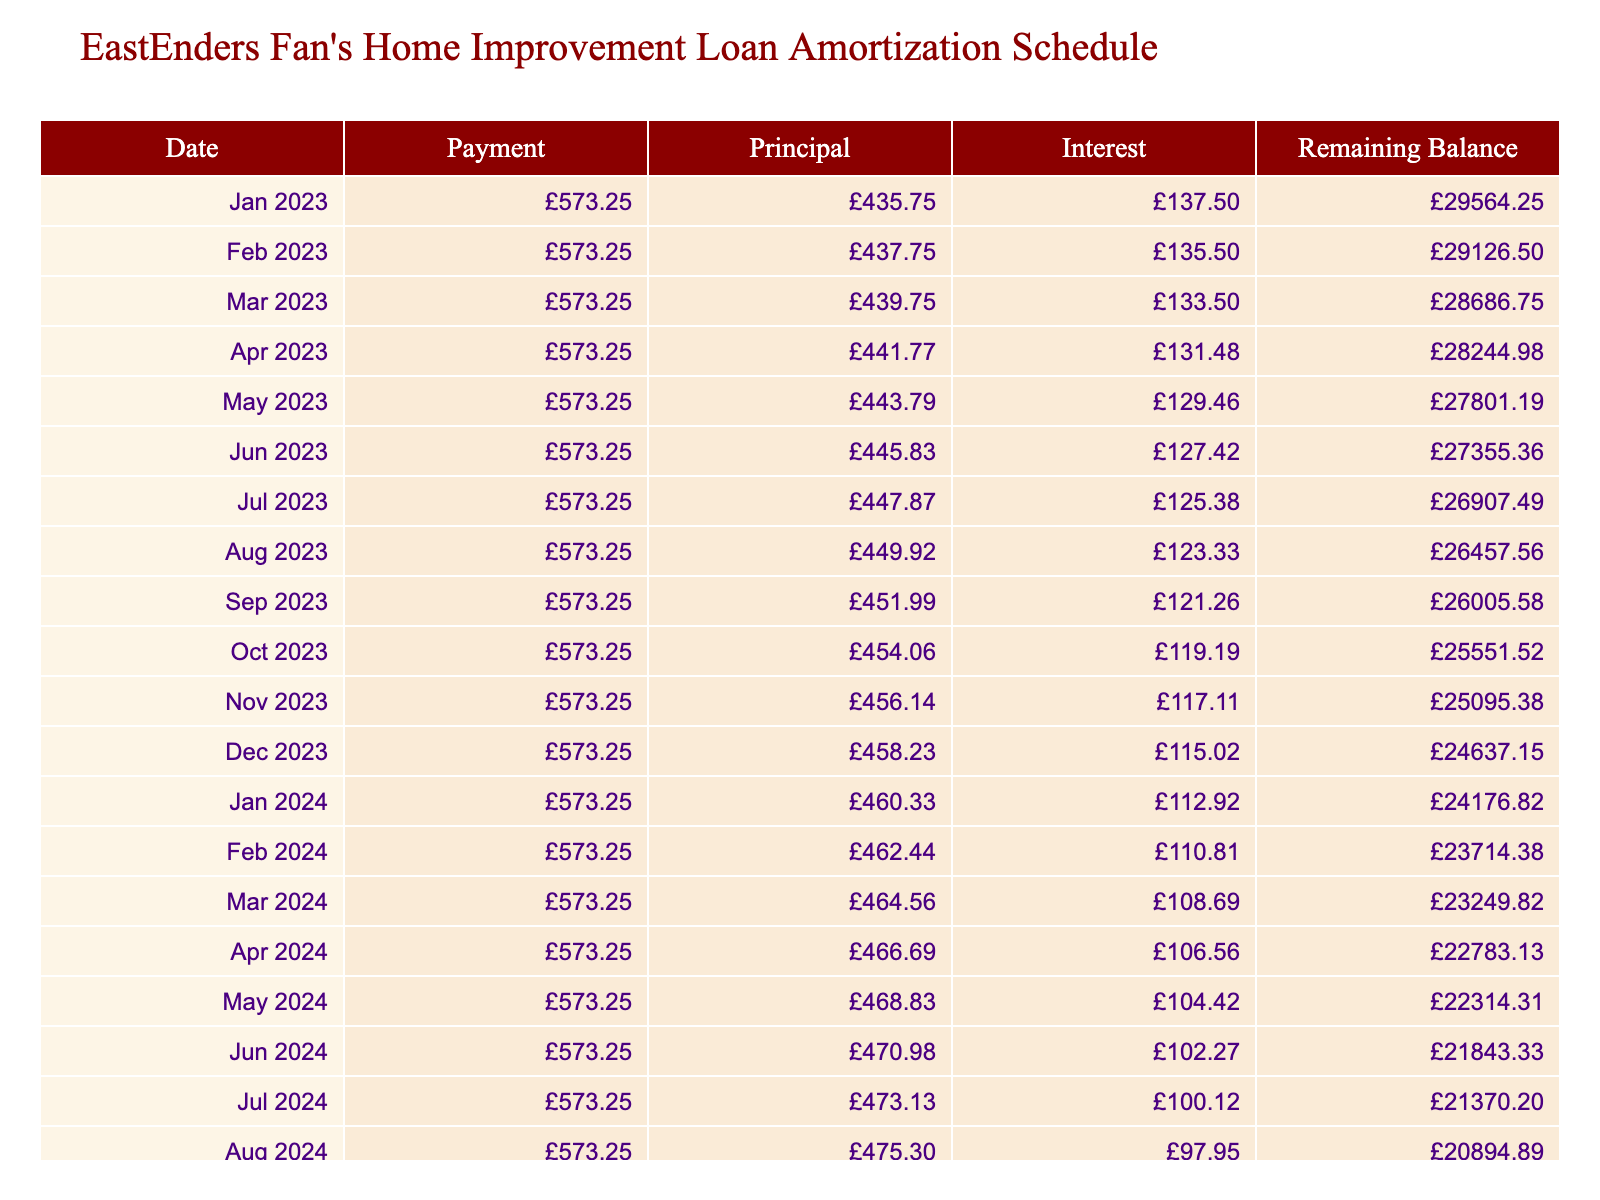What is the loan amount taken out for the home improvement loan? The loan amount is listed directly in the table under "Loan Amount," which shows £30,000.
Answer: £30,000 What is the total interest paid over the loan term? The total interest paid is also specified in the table under "Total Interest Paid," which indicates £4,395.
Answer: £4,395 How much is the monthly payment for this loan? The monthly payment figure is mentioned in the table in the "Monthly Payment" column, which shows £573.25.
Answer: £573.25 What is the remaining balance after the first month? To find the remaining balance after the first month, we take the initial loan amount (£30,000) and subtract the principal payment for the first month. The table will show the remaining balance after calculating this. The remaining balance would be displayed as less than the full loan amount, likely in the table.
Answer: [Value in the table] Is the interest rate of this loan greater than 5%? The interest rate is provided in the table as 5.5%, which is higher than 5%. Thus, the answer is true.
Answer: Yes What is the total payment over the loan term? The total payment is explicitly given in the "Total Payment" column of the table, amounting to £34,395.
Answer: £34,395 By the end of the loan term, what will the remaining balance be? At the end of the loan term, the remaining balance is always paid off, thus it will show £0 in the table. This value can be found by looking at the last row in the additional columns.
Answer: £0 What would be the average monthly interest paid over the life of the loan? The total interest paid is £4,395. To find the average monthly interest, divide this amount by the loan term in months (60). This averages about £73.25 per month, providing a sense of the monthly cost of interest.
Answer: £73.25 How much principal is paid off in the final month? To find the principal paid in the final month, look at the "Principal" column for the last entry in the table. It will show the specific payment made towards the principal for that final month. This value can be inferred by examining the last record in the schedule.
Answer: [Value in the table] 